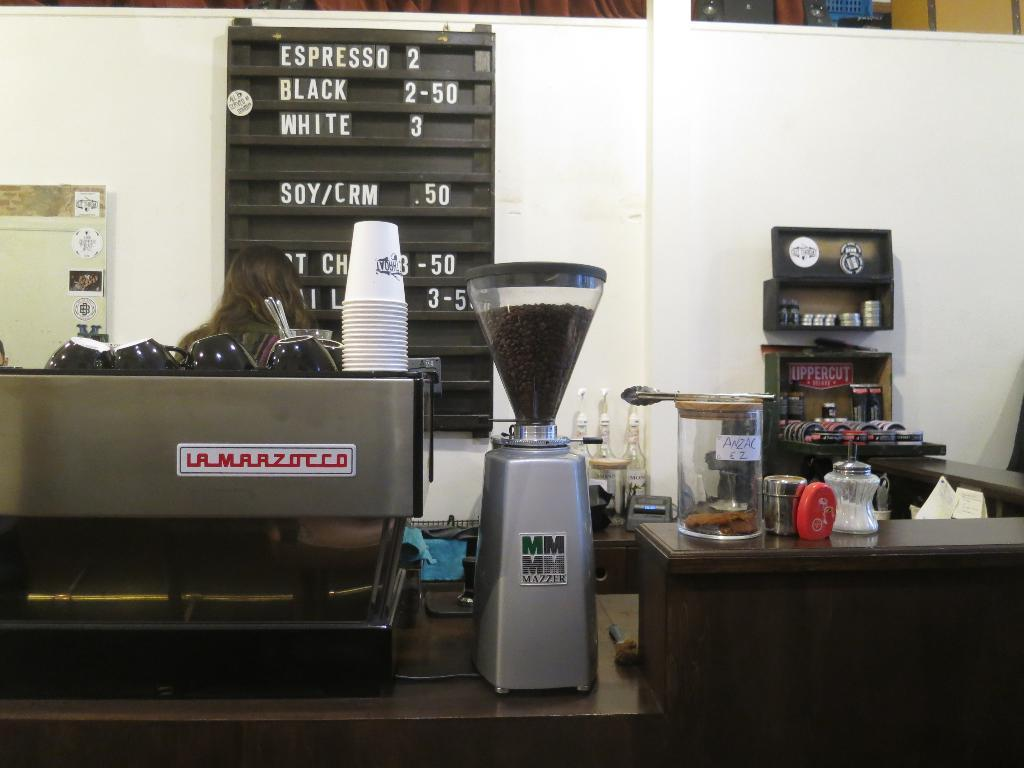<image>
Write a terse but informative summary of the picture. A coffee shop has a sign that displays their offerings, including Espresso. 